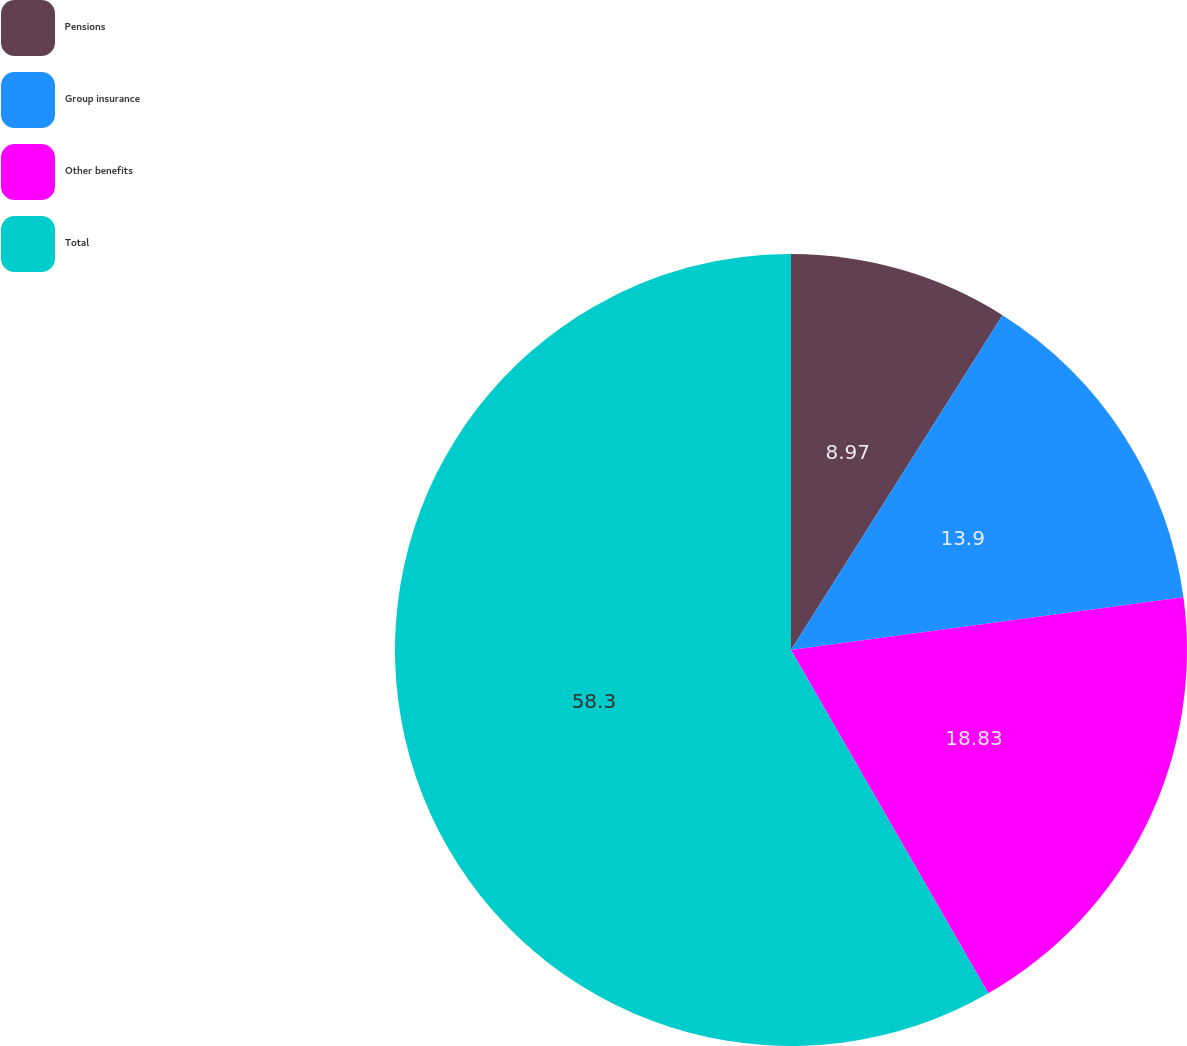<chart> <loc_0><loc_0><loc_500><loc_500><pie_chart><fcel>Pensions<fcel>Group insurance<fcel>Other benefits<fcel>Total<nl><fcel>8.97%<fcel>13.9%<fcel>18.83%<fcel>58.3%<nl></chart> 